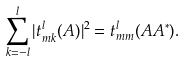<formula> <loc_0><loc_0><loc_500><loc_500>\sum _ { k = - l } ^ { l } | t _ { m k } ^ { l } ( A ) | ^ { 2 } = t _ { m m } ^ { l } ( A A ^ { \ast } ) .</formula> 